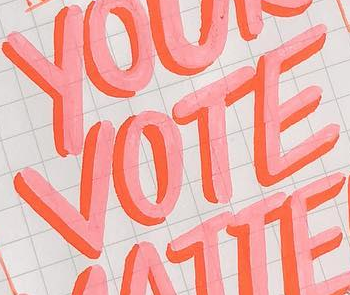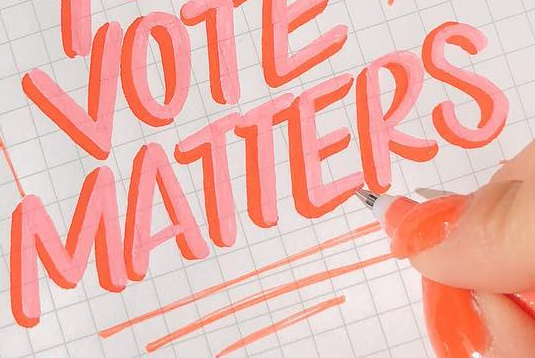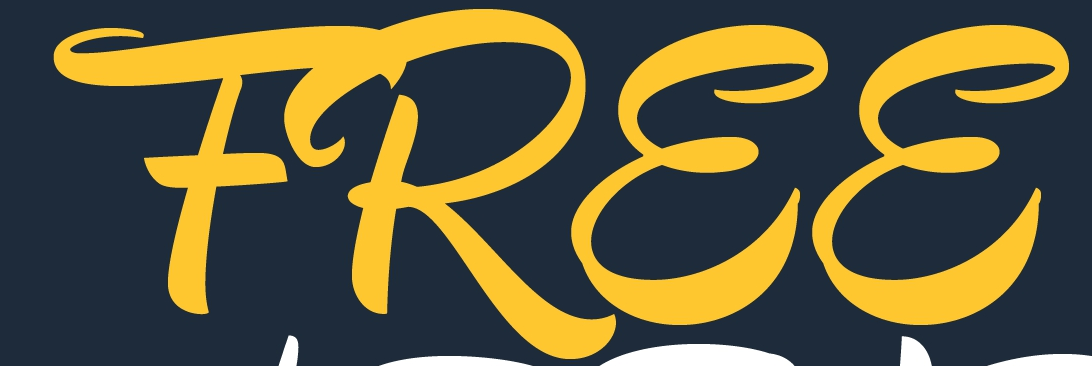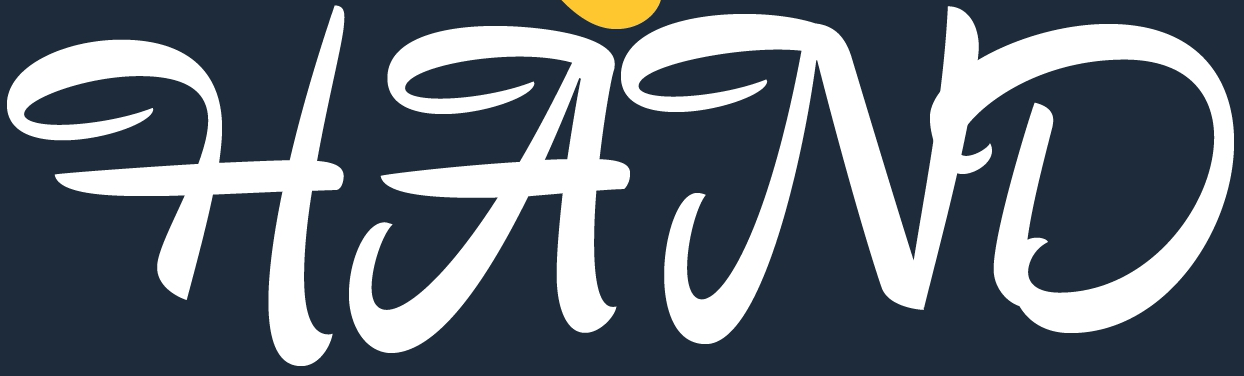What text is displayed in these images sequentially, separated by a semicolon? VOTE; MATTERS; FREE; HAND 